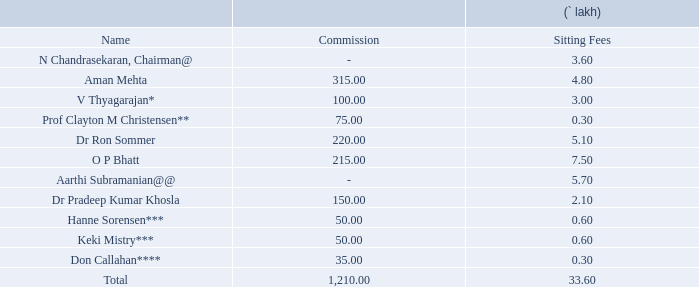Iv. details of the remuneration for the year ended march 31, 2019:
a. non-executive directors:
@ as a policy, n chandrasekaran, chairman, has abstained from receiving commission from the
company.
@@ in line with the internal guidelines of the company, no payment is made towards commission to
the non-executive directors of the company, who are in full time employment with any other tata
company.
* relinquished the position of independent director w.e.f. july 10, 2018.
** relinquished the position of independent director w.e.f. september 28, 2018.
*** appointed as an additional and independent director w.e.f. december 18, 2018.
**** appointed as an additional and independent director w.e.f. january 10, 2019.
who received the highest sitting fees? O p bhatt. Who received the highest commission? Aman mehta. What is the amount (in lakh) of the lowest sitting fee? 0.30. What is the average commision? 1,210/11 
Answer: 110. What is the difference between the maximum and minimum sitting fee? 7.5-0.3 
Answer: 7.2. What is the ratio of total commission to total sitting fees? 1,210/33.6 
Answer: 36.01. 